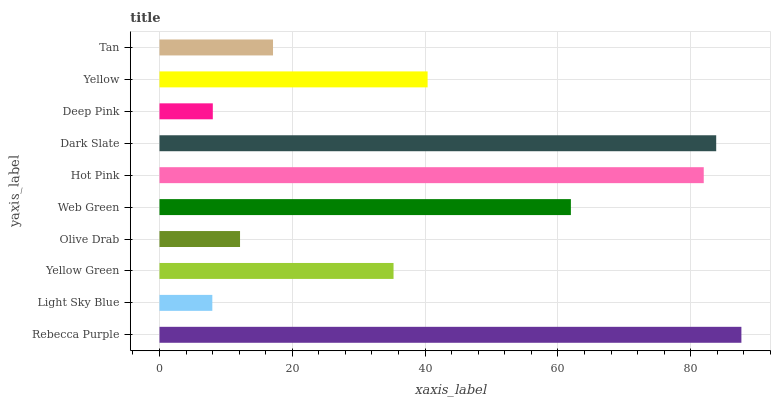Is Light Sky Blue the minimum?
Answer yes or no. Yes. Is Rebecca Purple the maximum?
Answer yes or no. Yes. Is Yellow Green the minimum?
Answer yes or no. No. Is Yellow Green the maximum?
Answer yes or no. No. Is Yellow Green greater than Light Sky Blue?
Answer yes or no. Yes. Is Light Sky Blue less than Yellow Green?
Answer yes or no. Yes. Is Light Sky Blue greater than Yellow Green?
Answer yes or no. No. Is Yellow Green less than Light Sky Blue?
Answer yes or no. No. Is Yellow the high median?
Answer yes or no. Yes. Is Yellow Green the low median?
Answer yes or no. Yes. Is Dark Slate the high median?
Answer yes or no. No. Is Rebecca Purple the low median?
Answer yes or no. No. 